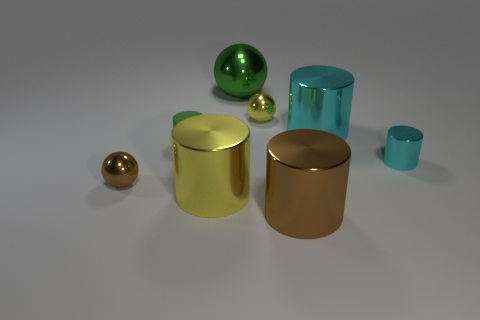Are there any other things that have the same material as the small green cylinder?
Offer a very short reply. No. Do the small matte cylinder and the big sphere have the same color?
Your response must be concise. Yes. There is a yellow metallic object in front of the large cyan object; what number of small green things are on the right side of it?
Your answer should be compact. 0. There is a big object behind the tiny yellow thing; does it have the same color as the tiny rubber cylinder?
Provide a short and direct response. Yes. There is a green thing in front of the large metallic cylinder that is to the right of the big brown metal thing; are there any yellow shiny cylinders that are on the left side of it?
Provide a short and direct response. No. There is a object that is in front of the green rubber object and right of the large brown metal thing; what is its shape?
Give a very brief answer. Cylinder. Is there a small object of the same color as the large ball?
Offer a very short reply. Yes. What color is the shiny cylinder right of the big metal cylinder that is to the right of the large brown metal cylinder?
Offer a terse response. Cyan. How big is the metallic object that is behind the small metal ball behind the small shiny thing right of the large brown object?
Make the answer very short. Large. Does the small yellow thing have the same material as the small ball on the left side of the green matte object?
Provide a short and direct response. Yes. 